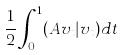<formula> <loc_0><loc_0><loc_500><loc_500>\frac { 1 } { 2 } \int _ { 0 } ^ { 1 } ( A v _ { t } | v _ { t } ) d t</formula> 